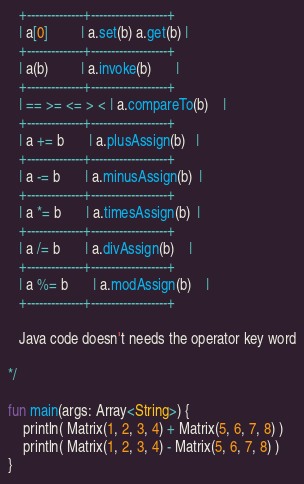Convert code to text. <code><loc_0><loc_0><loc_500><loc_500><_Kotlin_>   +--------------+-------------------+
   | a[0]         | a.set(b) a.get(b) |
   +--------------+-------------------+
   | a(b)         | a.invoke(b)       |
   +--------------+-------------------+
   | == >= <= > < | a.compareTo(b)    |
   +--------------+-------------------+
   | a += b       | a.plusAssign(b)   |
   +--------------+-------------------+
   | a -= b       | a.minusAssign(b)  |
   +--------------+-------------------+
   | a *= b       | a.timesAssign(b)  |
   +--------------+-------------------+
   | a /= b       | a.divAssign(b)    |
   +--------------+-------------------+
   | a %= b       | a.modAssign(b)    |
   +--------------+-------------------+

   Java code doesn't needs the operator key word

*/

fun main(args: Array<String>) {
    println( Matrix(1, 2, 3, 4) + Matrix(5, 6, 7, 8) )
    println( Matrix(1, 2, 3, 4) - Matrix(5, 6, 7, 8) )
}
</code> 